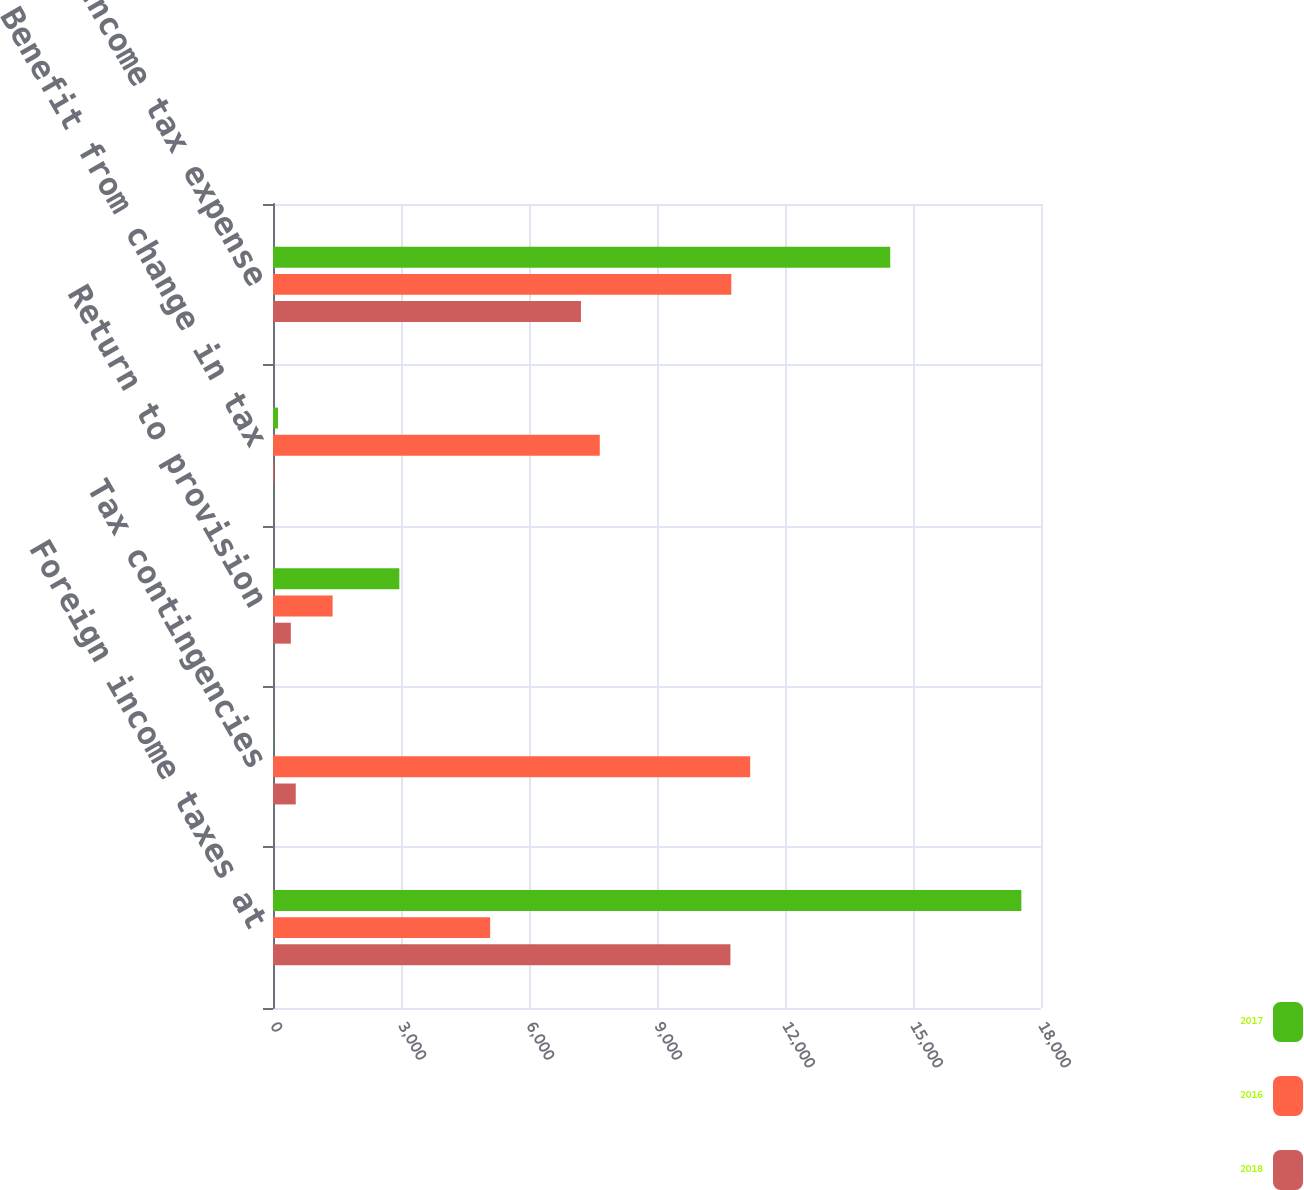<chart> <loc_0><loc_0><loc_500><loc_500><stacked_bar_chart><ecel><fcel>Foreign income taxes at<fcel>Tax contingencies<fcel>Return to provision<fcel>Benefit from change in tax<fcel>Income tax expense<nl><fcel>2017<fcel>17540<fcel>5<fcel>2961<fcel>117<fcel>14467<nl><fcel>2016<fcel>5089.5<fcel>11184<fcel>1397<fcel>7659<fcel>10742<nl><fcel>2018<fcel>10721<fcel>533<fcel>418<fcel>24<fcel>7218<nl></chart> 